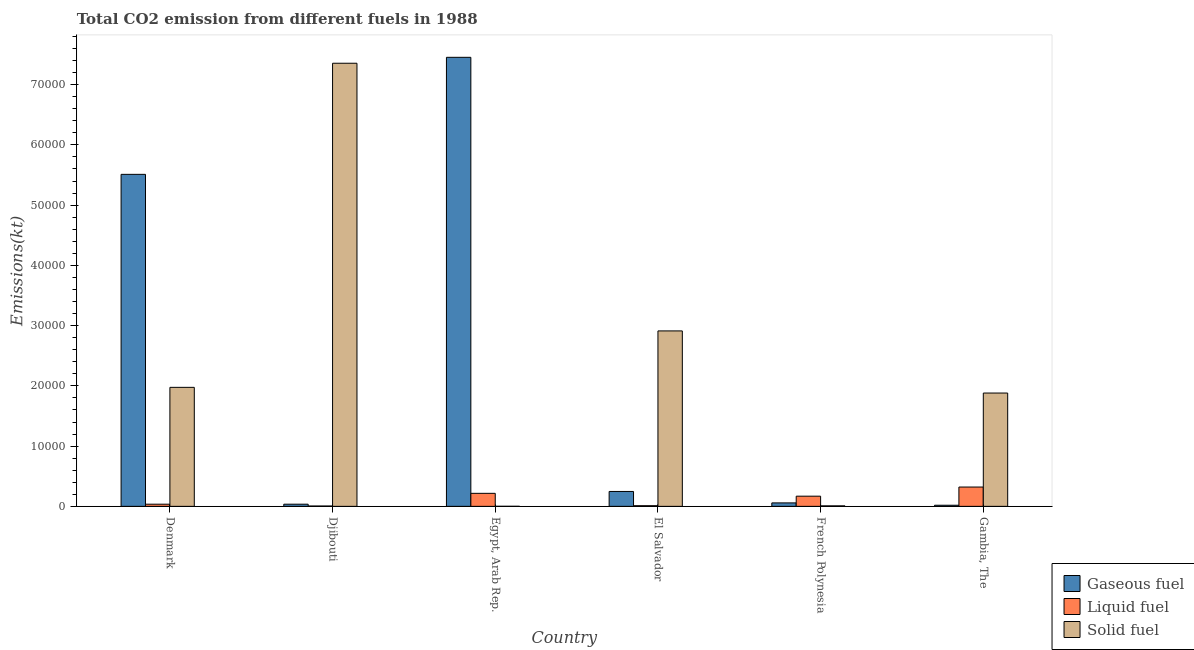How many different coloured bars are there?
Your answer should be compact. 3. How many groups of bars are there?
Provide a succinct answer. 6. Are the number of bars on each tick of the X-axis equal?
Keep it short and to the point. Yes. How many bars are there on the 4th tick from the left?
Give a very brief answer. 3. What is the label of the 6th group of bars from the left?
Keep it short and to the point. Gambia, The. What is the amount of co2 emissions from gaseous fuel in Gambia, The?
Your answer should be very brief. 183.35. Across all countries, what is the maximum amount of co2 emissions from liquid fuel?
Your answer should be very brief. 3204.96. Across all countries, what is the minimum amount of co2 emissions from gaseous fuel?
Keep it short and to the point. 183.35. In which country was the amount of co2 emissions from liquid fuel maximum?
Make the answer very short. Gambia, The. In which country was the amount of co2 emissions from liquid fuel minimum?
Provide a short and direct response. Djibouti. What is the total amount of co2 emissions from gaseous fuel in the graph?
Your answer should be very brief. 1.33e+05. What is the difference between the amount of co2 emissions from gaseous fuel in Denmark and that in Egypt, Arab Rep.?
Provide a succinct answer. -1.94e+04. What is the difference between the amount of co2 emissions from solid fuel in Gambia, The and the amount of co2 emissions from gaseous fuel in El Salvador?
Ensure brevity in your answer.  1.63e+04. What is the average amount of co2 emissions from liquid fuel per country?
Ensure brevity in your answer.  1261.45. What is the difference between the amount of co2 emissions from solid fuel and amount of co2 emissions from liquid fuel in Denmark?
Keep it short and to the point. 1.94e+04. What is the ratio of the amount of co2 emissions from liquid fuel in Djibouti to that in Egypt, Arab Rep.?
Your answer should be compact. 0.03. Is the difference between the amount of co2 emissions from liquid fuel in French Polynesia and Gambia, The greater than the difference between the amount of co2 emissions from gaseous fuel in French Polynesia and Gambia, The?
Your answer should be very brief. No. What is the difference between the highest and the second highest amount of co2 emissions from gaseous fuel?
Keep it short and to the point. 1.94e+04. What is the difference between the highest and the lowest amount of co2 emissions from gaseous fuel?
Your answer should be compact. 7.43e+04. In how many countries, is the amount of co2 emissions from liquid fuel greater than the average amount of co2 emissions from liquid fuel taken over all countries?
Provide a short and direct response. 3. Is the sum of the amount of co2 emissions from liquid fuel in Djibouti and Gambia, The greater than the maximum amount of co2 emissions from solid fuel across all countries?
Make the answer very short. No. What does the 3rd bar from the left in Egypt, Arab Rep. represents?
Your answer should be very brief. Solid fuel. What does the 2nd bar from the right in French Polynesia represents?
Ensure brevity in your answer.  Liquid fuel. How many countries are there in the graph?
Give a very brief answer. 6. What is the difference between two consecutive major ticks on the Y-axis?
Make the answer very short. 10000. Does the graph contain grids?
Ensure brevity in your answer.  No. How are the legend labels stacked?
Make the answer very short. Vertical. What is the title of the graph?
Make the answer very short. Total CO2 emission from different fuels in 1988. What is the label or title of the Y-axis?
Offer a terse response. Emissions(kt). What is the Emissions(kt) of Gaseous fuel in Denmark?
Offer a terse response. 5.51e+04. What is the Emissions(kt) in Liquid fuel in Denmark?
Ensure brevity in your answer.  355.7. What is the Emissions(kt) of Solid fuel in Denmark?
Provide a succinct answer. 1.98e+04. What is the Emissions(kt) of Gaseous fuel in Djibouti?
Provide a succinct answer. 355.7. What is the Emissions(kt) in Liquid fuel in Djibouti?
Your answer should be compact. 55.01. What is the Emissions(kt) in Solid fuel in Djibouti?
Your answer should be very brief. 7.35e+04. What is the Emissions(kt) of Gaseous fuel in Egypt, Arab Rep.?
Give a very brief answer. 7.45e+04. What is the Emissions(kt) of Liquid fuel in Egypt, Arab Rep.?
Keep it short and to the point. 2159.86. What is the Emissions(kt) of Solid fuel in Egypt, Arab Rep.?
Offer a very short reply. 7.33. What is the Emissions(kt) of Gaseous fuel in El Salvador?
Provide a succinct answer. 2471.56. What is the Emissions(kt) of Liquid fuel in El Salvador?
Your answer should be compact. 106.34. What is the Emissions(kt) of Solid fuel in El Salvador?
Provide a short and direct response. 2.91e+04. What is the Emissions(kt) of Gaseous fuel in French Polynesia?
Your answer should be compact. 572.05. What is the Emissions(kt) of Liquid fuel in French Polynesia?
Offer a very short reply. 1686.82. What is the Emissions(kt) of Solid fuel in French Polynesia?
Give a very brief answer. 80.67. What is the Emissions(kt) of Gaseous fuel in Gambia, The?
Offer a terse response. 183.35. What is the Emissions(kt) of Liquid fuel in Gambia, The?
Provide a short and direct response. 3204.96. What is the Emissions(kt) of Solid fuel in Gambia, The?
Make the answer very short. 1.88e+04. Across all countries, what is the maximum Emissions(kt) in Gaseous fuel?
Give a very brief answer. 7.45e+04. Across all countries, what is the maximum Emissions(kt) in Liquid fuel?
Make the answer very short. 3204.96. Across all countries, what is the maximum Emissions(kt) of Solid fuel?
Keep it short and to the point. 7.35e+04. Across all countries, what is the minimum Emissions(kt) in Gaseous fuel?
Provide a short and direct response. 183.35. Across all countries, what is the minimum Emissions(kt) of Liquid fuel?
Give a very brief answer. 55.01. Across all countries, what is the minimum Emissions(kt) of Solid fuel?
Offer a terse response. 7.33. What is the total Emissions(kt) of Gaseous fuel in the graph?
Your answer should be very brief. 1.33e+05. What is the total Emissions(kt) of Liquid fuel in the graph?
Provide a succinct answer. 7568.69. What is the total Emissions(kt) in Solid fuel in the graph?
Offer a very short reply. 1.41e+05. What is the difference between the Emissions(kt) of Gaseous fuel in Denmark and that in Djibouti?
Provide a short and direct response. 5.48e+04. What is the difference between the Emissions(kt) in Liquid fuel in Denmark and that in Djibouti?
Keep it short and to the point. 300.69. What is the difference between the Emissions(kt) of Solid fuel in Denmark and that in Djibouti?
Your answer should be very brief. -5.38e+04. What is the difference between the Emissions(kt) of Gaseous fuel in Denmark and that in Egypt, Arab Rep.?
Keep it short and to the point. -1.94e+04. What is the difference between the Emissions(kt) of Liquid fuel in Denmark and that in Egypt, Arab Rep.?
Give a very brief answer. -1804.16. What is the difference between the Emissions(kt) in Solid fuel in Denmark and that in Egypt, Arab Rep.?
Your answer should be compact. 1.97e+04. What is the difference between the Emissions(kt) in Gaseous fuel in Denmark and that in El Salvador?
Keep it short and to the point. 5.26e+04. What is the difference between the Emissions(kt) of Liquid fuel in Denmark and that in El Salvador?
Your response must be concise. 249.36. What is the difference between the Emissions(kt) of Solid fuel in Denmark and that in El Salvador?
Give a very brief answer. -9369.18. What is the difference between the Emissions(kt) in Gaseous fuel in Denmark and that in French Polynesia?
Your response must be concise. 5.45e+04. What is the difference between the Emissions(kt) in Liquid fuel in Denmark and that in French Polynesia?
Your response must be concise. -1331.12. What is the difference between the Emissions(kt) of Solid fuel in Denmark and that in French Polynesia?
Offer a terse response. 1.97e+04. What is the difference between the Emissions(kt) of Gaseous fuel in Denmark and that in Gambia, The?
Ensure brevity in your answer.  5.49e+04. What is the difference between the Emissions(kt) in Liquid fuel in Denmark and that in Gambia, The?
Offer a very short reply. -2849.26. What is the difference between the Emissions(kt) in Solid fuel in Denmark and that in Gambia, The?
Your answer should be compact. 942.42. What is the difference between the Emissions(kt) in Gaseous fuel in Djibouti and that in Egypt, Arab Rep.?
Provide a succinct answer. -7.42e+04. What is the difference between the Emissions(kt) of Liquid fuel in Djibouti and that in Egypt, Arab Rep.?
Make the answer very short. -2104.86. What is the difference between the Emissions(kt) of Solid fuel in Djibouti and that in Egypt, Arab Rep.?
Give a very brief answer. 7.35e+04. What is the difference between the Emissions(kt) of Gaseous fuel in Djibouti and that in El Salvador?
Provide a short and direct response. -2115.86. What is the difference between the Emissions(kt) in Liquid fuel in Djibouti and that in El Salvador?
Provide a short and direct response. -51.34. What is the difference between the Emissions(kt) in Solid fuel in Djibouti and that in El Salvador?
Ensure brevity in your answer.  4.44e+04. What is the difference between the Emissions(kt) in Gaseous fuel in Djibouti and that in French Polynesia?
Provide a succinct answer. -216.35. What is the difference between the Emissions(kt) of Liquid fuel in Djibouti and that in French Polynesia?
Give a very brief answer. -1631.82. What is the difference between the Emissions(kt) of Solid fuel in Djibouti and that in French Polynesia?
Keep it short and to the point. 7.35e+04. What is the difference between the Emissions(kt) of Gaseous fuel in Djibouti and that in Gambia, The?
Offer a very short reply. 172.35. What is the difference between the Emissions(kt) in Liquid fuel in Djibouti and that in Gambia, The?
Keep it short and to the point. -3149.95. What is the difference between the Emissions(kt) in Solid fuel in Djibouti and that in Gambia, The?
Your answer should be compact. 5.47e+04. What is the difference between the Emissions(kt) in Gaseous fuel in Egypt, Arab Rep. and that in El Salvador?
Your answer should be compact. 7.21e+04. What is the difference between the Emissions(kt) of Liquid fuel in Egypt, Arab Rep. and that in El Salvador?
Keep it short and to the point. 2053.52. What is the difference between the Emissions(kt) of Solid fuel in Egypt, Arab Rep. and that in El Salvador?
Offer a very short reply. -2.91e+04. What is the difference between the Emissions(kt) in Gaseous fuel in Egypt, Arab Rep. and that in French Polynesia?
Offer a very short reply. 7.40e+04. What is the difference between the Emissions(kt) of Liquid fuel in Egypt, Arab Rep. and that in French Polynesia?
Make the answer very short. 473.04. What is the difference between the Emissions(kt) of Solid fuel in Egypt, Arab Rep. and that in French Polynesia?
Provide a short and direct response. -73.34. What is the difference between the Emissions(kt) in Gaseous fuel in Egypt, Arab Rep. and that in Gambia, The?
Your answer should be very brief. 7.43e+04. What is the difference between the Emissions(kt) in Liquid fuel in Egypt, Arab Rep. and that in Gambia, The?
Make the answer very short. -1045.1. What is the difference between the Emissions(kt) in Solid fuel in Egypt, Arab Rep. and that in Gambia, The?
Offer a very short reply. -1.88e+04. What is the difference between the Emissions(kt) in Gaseous fuel in El Salvador and that in French Polynesia?
Provide a succinct answer. 1899.51. What is the difference between the Emissions(kt) in Liquid fuel in El Salvador and that in French Polynesia?
Make the answer very short. -1580.48. What is the difference between the Emissions(kt) of Solid fuel in El Salvador and that in French Polynesia?
Ensure brevity in your answer.  2.90e+04. What is the difference between the Emissions(kt) in Gaseous fuel in El Salvador and that in Gambia, The?
Offer a very short reply. 2288.21. What is the difference between the Emissions(kt) in Liquid fuel in El Salvador and that in Gambia, The?
Offer a very short reply. -3098.61. What is the difference between the Emissions(kt) in Solid fuel in El Salvador and that in Gambia, The?
Provide a short and direct response. 1.03e+04. What is the difference between the Emissions(kt) of Gaseous fuel in French Polynesia and that in Gambia, The?
Ensure brevity in your answer.  388.7. What is the difference between the Emissions(kt) in Liquid fuel in French Polynesia and that in Gambia, The?
Your answer should be very brief. -1518.14. What is the difference between the Emissions(kt) of Solid fuel in French Polynesia and that in Gambia, The?
Offer a terse response. -1.87e+04. What is the difference between the Emissions(kt) of Gaseous fuel in Denmark and the Emissions(kt) of Liquid fuel in Djibouti?
Offer a terse response. 5.51e+04. What is the difference between the Emissions(kt) in Gaseous fuel in Denmark and the Emissions(kt) in Solid fuel in Djibouti?
Your answer should be very brief. -1.84e+04. What is the difference between the Emissions(kt) in Liquid fuel in Denmark and the Emissions(kt) in Solid fuel in Djibouti?
Offer a terse response. -7.32e+04. What is the difference between the Emissions(kt) in Gaseous fuel in Denmark and the Emissions(kt) in Liquid fuel in Egypt, Arab Rep.?
Give a very brief answer. 5.29e+04. What is the difference between the Emissions(kt) of Gaseous fuel in Denmark and the Emissions(kt) of Solid fuel in Egypt, Arab Rep.?
Your answer should be compact. 5.51e+04. What is the difference between the Emissions(kt) of Liquid fuel in Denmark and the Emissions(kt) of Solid fuel in Egypt, Arab Rep.?
Offer a very short reply. 348.37. What is the difference between the Emissions(kt) in Gaseous fuel in Denmark and the Emissions(kt) in Liquid fuel in El Salvador?
Give a very brief answer. 5.50e+04. What is the difference between the Emissions(kt) in Gaseous fuel in Denmark and the Emissions(kt) in Solid fuel in El Salvador?
Keep it short and to the point. 2.60e+04. What is the difference between the Emissions(kt) in Liquid fuel in Denmark and the Emissions(kt) in Solid fuel in El Salvador?
Provide a short and direct response. -2.88e+04. What is the difference between the Emissions(kt) in Gaseous fuel in Denmark and the Emissions(kt) in Liquid fuel in French Polynesia?
Offer a terse response. 5.34e+04. What is the difference between the Emissions(kt) in Gaseous fuel in Denmark and the Emissions(kt) in Solid fuel in French Polynesia?
Offer a very short reply. 5.50e+04. What is the difference between the Emissions(kt) of Liquid fuel in Denmark and the Emissions(kt) of Solid fuel in French Polynesia?
Provide a succinct answer. 275.02. What is the difference between the Emissions(kt) in Gaseous fuel in Denmark and the Emissions(kt) in Liquid fuel in Gambia, The?
Ensure brevity in your answer.  5.19e+04. What is the difference between the Emissions(kt) in Gaseous fuel in Denmark and the Emissions(kt) in Solid fuel in Gambia, The?
Offer a very short reply. 3.63e+04. What is the difference between the Emissions(kt) of Liquid fuel in Denmark and the Emissions(kt) of Solid fuel in Gambia, The?
Offer a terse response. -1.85e+04. What is the difference between the Emissions(kt) in Gaseous fuel in Djibouti and the Emissions(kt) in Liquid fuel in Egypt, Arab Rep.?
Offer a very short reply. -1804.16. What is the difference between the Emissions(kt) of Gaseous fuel in Djibouti and the Emissions(kt) of Solid fuel in Egypt, Arab Rep.?
Ensure brevity in your answer.  348.37. What is the difference between the Emissions(kt) in Liquid fuel in Djibouti and the Emissions(kt) in Solid fuel in Egypt, Arab Rep.?
Your response must be concise. 47.67. What is the difference between the Emissions(kt) in Gaseous fuel in Djibouti and the Emissions(kt) in Liquid fuel in El Salvador?
Your answer should be compact. 249.36. What is the difference between the Emissions(kt) in Gaseous fuel in Djibouti and the Emissions(kt) in Solid fuel in El Salvador?
Make the answer very short. -2.88e+04. What is the difference between the Emissions(kt) in Liquid fuel in Djibouti and the Emissions(kt) in Solid fuel in El Salvador?
Your answer should be very brief. -2.91e+04. What is the difference between the Emissions(kt) of Gaseous fuel in Djibouti and the Emissions(kt) of Liquid fuel in French Polynesia?
Your response must be concise. -1331.12. What is the difference between the Emissions(kt) of Gaseous fuel in Djibouti and the Emissions(kt) of Solid fuel in French Polynesia?
Your answer should be compact. 275.02. What is the difference between the Emissions(kt) of Liquid fuel in Djibouti and the Emissions(kt) of Solid fuel in French Polynesia?
Ensure brevity in your answer.  -25.67. What is the difference between the Emissions(kt) of Gaseous fuel in Djibouti and the Emissions(kt) of Liquid fuel in Gambia, The?
Your response must be concise. -2849.26. What is the difference between the Emissions(kt) in Gaseous fuel in Djibouti and the Emissions(kt) in Solid fuel in Gambia, The?
Give a very brief answer. -1.85e+04. What is the difference between the Emissions(kt) of Liquid fuel in Djibouti and the Emissions(kt) of Solid fuel in Gambia, The?
Offer a very short reply. -1.88e+04. What is the difference between the Emissions(kt) in Gaseous fuel in Egypt, Arab Rep. and the Emissions(kt) in Liquid fuel in El Salvador?
Offer a very short reply. 7.44e+04. What is the difference between the Emissions(kt) in Gaseous fuel in Egypt, Arab Rep. and the Emissions(kt) in Solid fuel in El Salvador?
Offer a terse response. 4.54e+04. What is the difference between the Emissions(kt) in Liquid fuel in Egypt, Arab Rep. and the Emissions(kt) in Solid fuel in El Salvador?
Keep it short and to the point. -2.70e+04. What is the difference between the Emissions(kt) in Gaseous fuel in Egypt, Arab Rep. and the Emissions(kt) in Liquid fuel in French Polynesia?
Provide a short and direct response. 7.28e+04. What is the difference between the Emissions(kt) in Gaseous fuel in Egypt, Arab Rep. and the Emissions(kt) in Solid fuel in French Polynesia?
Provide a short and direct response. 7.45e+04. What is the difference between the Emissions(kt) in Liquid fuel in Egypt, Arab Rep. and the Emissions(kt) in Solid fuel in French Polynesia?
Offer a very short reply. 2079.19. What is the difference between the Emissions(kt) in Gaseous fuel in Egypt, Arab Rep. and the Emissions(kt) in Liquid fuel in Gambia, The?
Offer a very short reply. 7.13e+04. What is the difference between the Emissions(kt) of Gaseous fuel in Egypt, Arab Rep. and the Emissions(kt) of Solid fuel in Gambia, The?
Offer a very short reply. 5.57e+04. What is the difference between the Emissions(kt) of Liquid fuel in Egypt, Arab Rep. and the Emissions(kt) of Solid fuel in Gambia, The?
Provide a short and direct response. -1.66e+04. What is the difference between the Emissions(kt) of Gaseous fuel in El Salvador and the Emissions(kt) of Liquid fuel in French Polynesia?
Your answer should be very brief. 784.74. What is the difference between the Emissions(kt) in Gaseous fuel in El Salvador and the Emissions(kt) in Solid fuel in French Polynesia?
Offer a very short reply. 2390.88. What is the difference between the Emissions(kt) of Liquid fuel in El Salvador and the Emissions(kt) of Solid fuel in French Polynesia?
Offer a terse response. 25.67. What is the difference between the Emissions(kt) in Gaseous fuel in El Salvador and the Emissions(kt) in Liquid fuel in Gambia, The?
Your answer should be compact. -733.4. What is the difference between the Emissions(kt) of Gaseous fuel in El Salvador and the Emissions(kt) of Solid fuel in Gambia, The?
Your answer should be compact. -1.63e+04. What is the difference between the Emissions(kt) of Liquid fuel in El Salvador and the Emissions(kt) of Solid fuel in Gambia, The?
Your answer should be compact. -1.87e+04. What is the difference between the Emissions(kt) of Gaseous fuel in French Polynesia and the Emissions(kt) of Liquid fuel in Gambia, The?
Offer a very short reply. -2632.91. What is the difference between the Emissions(kt) of Gaseous fuel in French Polynesia and the Emissions(kt) of Solid fuel in Gambia, The?
Your answer should be compact. -1.82e+04. What is the difference between the Emissions(kt) of Liquid fuel in French Polynesia and the Emissions(kt) of Solid fuel in Gambia, The?
Your response must be concise. -1.71e+04. What is the average Emissions(kt) in Gaseous fuel per country?
Your answer should be compact. 2.22e+04. What is the average Emissions(kt) in Liquid fuel per country?
Offer a very short reply. 1261.45. What is the average Emissions(kt) in Solid fuel per country?
Your response must be concise. 2.36e+04. What is the difference between the Emissions(kt) of Gaseous fuel and Emissions(kt) of Liquid fuel in Denmark?
Provide a succinct answer. 5.48e+04. What is the difference between the Emissions(kt) in Gaseous fuel and Emissions(kt) in Solid fuel in Denmark?
Make the answer very short. 3.54e+04. What is the difference between the Emissions(kt) of Liquid fuel and Emissions(kt) of Solid fuel in Denmark?
Make the answer very short. -1.94e+04. What is the difference between the Emissions(kt) of Gaseous fuel and Emissions(kt) of Liquid fuel in Djibouti?
Your answer should be compact. 300.69. What is the difference between the Emissions(kt) in Gaseous fuel and Emissions(kt) in Solid fuel in Djibouti?
Keep it short and to the point. -7.32e+04. What is the difference between the Emissions(kt) in Liquid fuel and Emissions(kt) in Solid fuel in Djibouti?
Make the answer very short. -7.35e+04. What is the difference between the Emissions(kt) of Gaseous fuel and Emissions(kt) of Liquid fuel in Egypt, Arab Rep.?
Provide a short and direct response. 7.24e+04. What is the difference between the Emissions(kt) in Gaseous fuel and Emissions(kt) in Solid fuel in Egypt, Arab Rep.?
Your answer should be compact. 7.45e+04. What is the difference between the Emissions(kt) in Liquid fuel and Emissions(kt) in Solid fuel in Egypt, Arab Rep.?
Provide a succinct answer. 2152.53. What is the difference between the Emissions(kt) of Gaseous fuel and Emissions(kt) of Liquid fuel in El Salvador?
Your answer should be very brief. 2365.22. What is the difference between the Emissions(kt) in Gaseous fuel and Emissions(kt) in Solid fuel in El Salvador?
Keep it short and to the point. -2.66e+04. What is the difference between the Emissions(kt) of Liquid fuel and Emissions(kt) of Solid fuel in El Salvador?
Give a very brief answer. -2.90e+04. What is the difference between the Emissions(kt) of Gaseous fuel and Emissions(kt) of Liquid fuel in French Polynesia?
Ensure brevity in your answer.  -1114.77. What is the difference between the Emissions(kt) in Gaseous fuel and Emissions(kt) in Solid fuel in French Polynesia?
Make the answer very short. 491.38. What is the difference between the Emissions(kt) in Liquid fuel and Emissions(kt) in Solid fuel in French Polynesia?
Ensure brevity in your answer.  1606.15. What is the difference between the Emissions(kt) of Gaseous fuel and Emissions(kt) of Liquid fuel in Gambia, The?
Ensure brevity in your answer.  -3021.61. What is the difference between the Emissions(kt) in Gaseous fuel and Emissions(kt) in Solid fuel in Gambia, The?
Keep it short and to the point. -1.86e+04. What is the difference between the Emissions(kt) of Liquid fuel and Emissions(kt) of Solid fuel in Gambia, The?
Provide a short and direct response. -1.56e+04. What is the ratio of the Emissions(kt) in Gaseous fuel in Denmark to that in Djibouti?
Your answer should be very brief. 154.93. What is the ratio of the Emissions(kt) in Liquid fuel in Denmark to that in Djibouti?
Offer a terse response. 6.47. What is the ratio of the Emissions(kt) of Solid fuel in Denmark to that in Djibouti?
Keep it short and to the point. 0.27. What is the ratio of the Emissions(kt) of Gaseous fuel in Denmark to that in Egypt, Arab Rep.?
Give a very brief answer. 0.74. What is the ratio of the Emissions(kt) of Liquid fuel in Denmark to that in Egypt, Arab Rep.?
Keep it short and to the point. 0.16. What is the ratio of the Emissions(kt) of Solid fuel in Denmark to that in Egypt, Arab Rep.?
Ensure brevity in your answer.  2693. What is the ratio of the Emissions(kt) in Gaseous fuel in Denmark to that in El Salvador?
Offer a very short reply. 22.3. What is the ratio of the Emissions(kt) in Liquid fuel in Denmark to that in El Salvador?
Provide a short and direct response. 3.34. What is the ratio of the Emissions(kt) of Solid fuel in Denmark to that in El Salvador?
Provide a short and direct response. 0.68. What is the ratio of the Emissions(kt) in Gaseous fuel in Denmark to that in French Polynesia?
Keep it short and to the point. 96.33. What is the ratio of the Emissions(kt) of Liquid fuel in Denmark to that in French Polynesia?
Offer a very short reply. 0.21. What is the ratio of the Emissions(kt) of Solid fuel in Denmark to that in French Polynesia?
Your answer should be very brief. 244.82. What is the ratio of the Emissions(kt) in Gaseous fuel in Denmark to that in Gambia, The?
Offer a terse response. 300.56. What is the ratio of the Emissions(kt) of Liquid fuel in Denmark to that in Gambia, The?
Make the answer very short. 0.11. What is the ratio of the Emissions(kt) in Solid fuel in Denmark to that in Gambia, The?
Provide a short and direct response. 1.05. What is the ratio of the Emissions(kt) of Gaseous fuel in Djibouti to that in Egypt, Arab Rep.?
Make the answer very short. 0. What is the ratio of the Emissions(kt) of Liquid fuel in Djibouti to that in Egypt, Arab Rep.?
Your answer should be compact. 0.03. What is the ratio of the Emissions(kt) in Solid fuel in Djibouti to that in Egypt, Arab Rep.?
Keep it short and to the point. 1.00e+04. What is the ratio of the Emissions(kt) of Gaseous fuel in Djibouti to that in El Salvador?
Provide a succinct answer. 0.14. What is the ratio of the Emissions(kt) of Liquid fuel in Djibouti to that in El Salvador?
Give a very brief answer. 0.52. What is the ratio of the Emissions(kt) in Solid fuel in Djibouti to that in El Salvador?
Give a very brief answer. 2.53. What is the ratio of the Emissions(kt) of Gaseous fuel in Djibouti to that in French Polynesia?
Offer a very short reply. 0.62. What is the ratio of the Emissions(kt) in Liquid fuel in Djibouti to that in French Polynesia?
Your answer should be compact. 0.03. What is the ratio of the Emissions(kt) of Solid fuel in Djibouti to that in French Polynesia?
Keep it short and to the point. 911.68. What is the ratio of the Emissions(kt) in Gaseous fuel in Djibouti to that in Gambia, The?
Make the answer very short. 1.94. What is the ratio of the Emissions(kt) of Liquid fuel in Djibouti to that in Gambia, The?
Provide a short and direct response. 0.02. What is the ratio of the Emissions(kt) in Solid fuel in Djibouti to that in Gambia, The?
Your answer should be compact. 3.91. What is the ratio of the Emissions(kt) in Gaseous fuel in Egypt, Arab Rep. to that in El Salvador?
Offer a terse response. 30.16. What is the ratio of the Emissions(kt) in Liquid fuel in Egypt, Arab Rep. to that in El Salvador?
Your answer should be very brief. 20.31. What is the ratio of the Emissions(kt) of Solid fuel in Egypt, Arab Rep. to that in El Salvador?
Give a very brief answer. 0. What is the ratio of the Emissions(kt) of Gaseous fuel in Egypt, Arab Rep. to that in French Polynesia?
Provide a short and direct response. 130.29. What is the ratio of the Emissions(kt) of Liquid fuel in Egypt, Arab Rep. to that in French Polynesia?
Provide a short and direct response. 1.28. What is the ratio of the Emissions(kt) of Solid fuel in Egypt, Arab Rep. to that in French Polynesia?
Your response must be concise. 0.09. What is the ratio of the Emissions(kt) of Gaseous fuel in Egypt, Arab Rep. to that in Gambia, The?
Offer a terse response. 406.5. What is the ratio of the Emissions(kt) in Liquid fuel in Egypt, Arab Rep. to that in Gambia, The?
Keep it short and to the point. 0.67. What is the ratio of the Emissions(kt) of Solid fuel in Egypt, Arab Rep. to that in Gambia, The?
Your response must be concise. 0. What is the ratio of the Emissions(kt) of Gaseous fuel in El Salvador to that in French Polynesia?
Ensure brevity in your answer.  4.32. What is the ratio of the Emissions(kt) of Liquid fuel in El Salvador to that in French Polynesia?
Give a very brief answer. 0.06. What is the ratio of the Emissions(kt) in Solid fuel in El Salvador to that in French Polynesia?
Provide a short and direct response. 360.95. What is the ratio of the Emissions(kt) in Gaseous fuel in El Salvador to that in Gambia, The?
Your response must be concise. 13.48. What is the ratio of the Emissions(kt) of Liquid fuel in El Salvador to that in Gambia, The?
Offer a terse response. 0.03. What is the ratio of the Emissions(kt) in Solid fuel in El Salvador to that in Gambia, The?
Make the answer very short. 1.55. What is the ratio of the Emissions(kt) in Gaseous fuel in French Polynesia to that in Gambia, The?
Make the answer very short. 3.12. What is the ratio of the Emissions(kt) of Liquid fuel in French Polynesia to that in Gambia, The?
Your response must be concise. 0.53. What is the ratio of the Emissions(kt) in Solid fuel in French Polynesia to that in Gambia, The?
Make the answer very short. 0. What is the difference between the highest and the second highest Emissions(kt) in Gaseous fuel?
Your answer should be very brief. 1.94e+04. What is the difference between the highest and the second highest Emissions(kt) of Liquid fuel?
Offer a terse response. 1045.1. What is the difference between the highest and the second highest Emissions(kt) of Solid fuel?
Offer a terse response. 4.44e+04. What is the difference between the highest and the lowest Emissions(kt) in Gaseous fuel?
Your response must be concise. 7.43e+04. What is the difference between the highest and the lowest Emissions(kt) of Liquid fuel?
Provide a short and direct response. 3149.95. What is the difference between the highest and the lowest Emissions(kt) in Solid fuel?
Offer a terse response. 7.35e+04. 